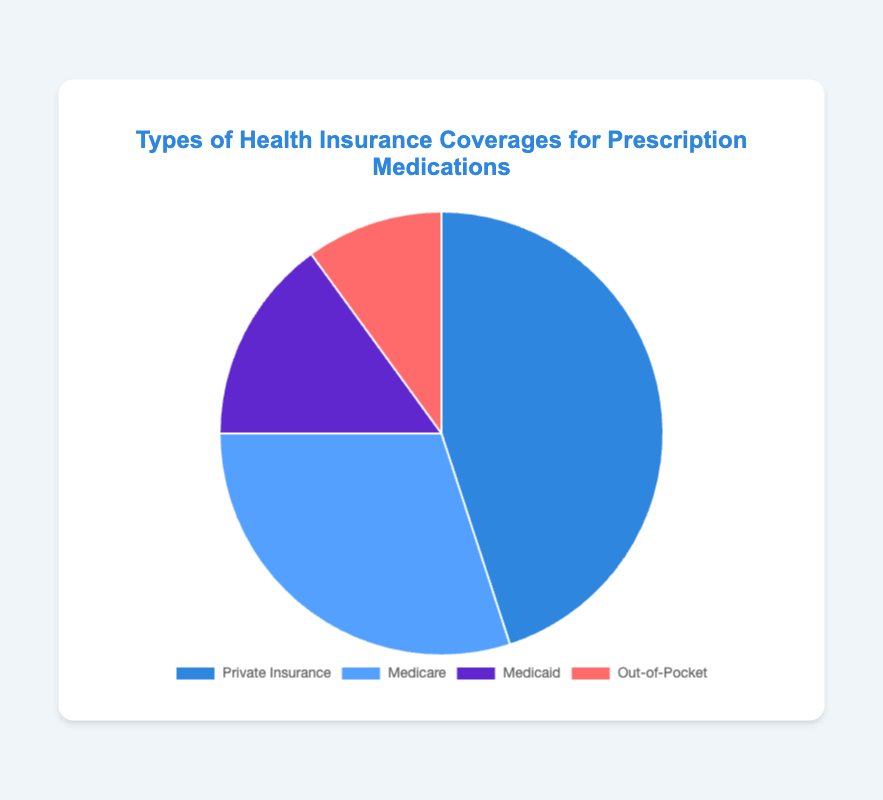Which type of health insurance coverage has the highest percentage for prescription medications? The slice representing Private Insurance is the largest in the pie chart. This indicates it has the highest percentage among the coverage types.
Answer: Private Insurance Which type of health insurance coverage has the lowest percentage for prescription medications? The slice representing Out-of-Pocket is the smallest in the pie chart. This indicates it has the lowest percentage among the coverage types.
Answer: Out-of-Pocket By how much does the percentage of Private Insurance exceed Medicare? The pie chart shows Private Insurance at 45% and Medicare at 30%. The difference is 45% - 30%.
Answer: 15% What is the sum of the percentages for Medicare and Medicaid coverages? The pie chart gives Medicare at 30% and Medicaid at 15%. Adding these together gives 30% + 15%.
Answer: 45% Which coverage type is depicted by the slice in red? The pie chart shows that Out-of-Pocket is represented by a red slice.
Answer: Out-of-Pocket What is the combined percentage of Private Insurance and Out-of-Pocket coverage? The chart shows Private Insurance at 45% and Out-of-Pocket at 10%. Adding these together gives 45% + 10%.
Answer: 55% How does Medicaid coverage compare to Out-of-Pocket coverage? The chart shows Medicaid at 15% and Out-of-Pocket at 10%. Comparing these, Medicaid has a higher percentage.
Answer: Medicaid is higher What is the difference between the coverage percentages of Private Insurance and Medicaid? The chart shows Private Insurance at 45% and Medicaid at 15%. The difference is 45% - 15%.
Answer: 30% What is the percentage of non-Medicare coverages combined? To find the combined percentage for coverages other than Medicare, sum Private Insurance (45%), Medicaid (15%), and Out-of-Pocket (10%). The combined percentage is 45% + 15% + 10%.
Answer: 70% Which coverage types make up more than half of the total coverage combined? The chart shows Private Insurance (45%) and Medicare (30%). Their combined percentage is 45% + 30%.
Answer: Private Insurance and Medicare 